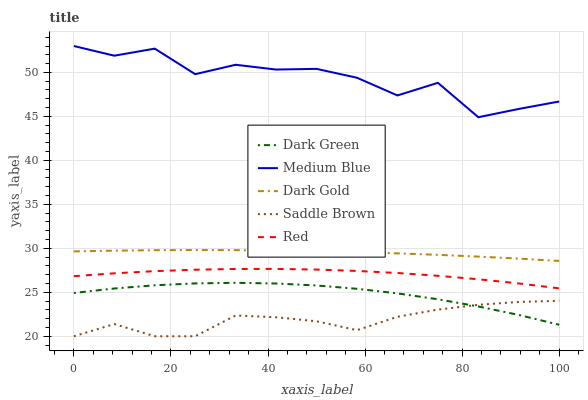Does Saddle Brown have the minimum area under the curve?
Answer yes or no. Yes. Does Medium Blue have the maximum area under the curve?
Answer yes or no. Yes. Does Medium Blue have the minimum area under the curve?
Answer yes or no. No. Does Saddle Brown have the maximum area under the curve?
Answer yes or no. No. Is Dark Gold the smoothest?
Answer yes or no. Yes. Is Medium Blue the roughest?
Answer yes or no. Yes. Is Saddle Brown the smoothest?
Answer yes or no. No. Is Saddle Brown the roughest?
Answer yes or no. No. Does Saddle Brown have the lowest value?
Answer yes or no. Yes. Does Medium Blue have the lowest value?
Answer yes or no. No. Does Medium Blue have the highest value?
Answer yes or no. Yes. Does Saddle Brown have the highest value?
Answer yes or no. No. Is Dark Green less than Dark Gold?
Answer yes or no. Yes. Is Dark Gold greater than Dark Green?
Answer yes or no. Yes. Does Saddle Brown intersect Dark Green?
Answer yes or no. Yes. Is Saddle Brown less than Dark Green?
Answer yes or no. No. Is Saddle Brown greater than Dark Green?
Answer yes or no. No. Does Dark Green intersect Dark Gold?
Answer yes or no. No. 